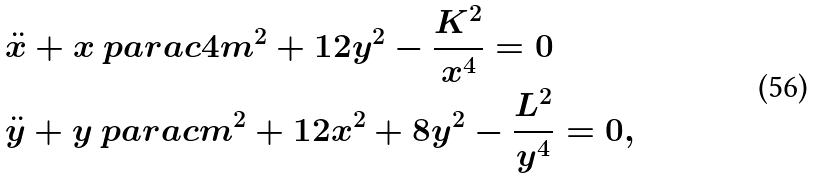<formula> <loc_0><loc_0><loc_500><loc_500>& \overset { \, . . } { x } + x \ p a r a c { 4 m ^ { 2 } + 1 2 y ^ { 2 } - \frac { K ^ { 2 } } { x ^ { 4 } } } = 0 \\ & \overset { \, . . } { y } + y \ p a r a c { m ^ { 2 } + 1 2 x ^ { 2 } + 8 y ^ { 2 } - \frac { L ^ { 2 } } { y ^ { 4 } } } = 0 ,</formula> 